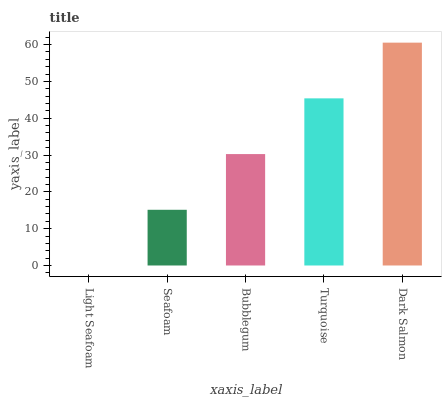Is Light Seafoam the minimum?
Answer yes or no. Yes. Is Dark Salmon the maximum?
Answer yes or no. Yes. Is Seafoam the minimum?
Answer yes or no. No. Is Seafoam the maximum?
Answer yes or no. No. Is Seafoam greater than Light Seafoam?
Answer yes or no. Yes. Is Light Seafoam less than Seafoam?
Answer yes or no. Yes. Is Light Seafoam greater than Seafoam?
Answer yes or no. No. Is Seafoam less than Light Seafoam?
Answer yes or no. No. Is Bubblegum the high median?
Answer yes or no. Yes. Is Bubblegum the low median?
Answer yes or no. Yes. Is Seafoam the high median?
Answer yes or no. No. Is Turquoise the low median?
Answer yes or no. No. 